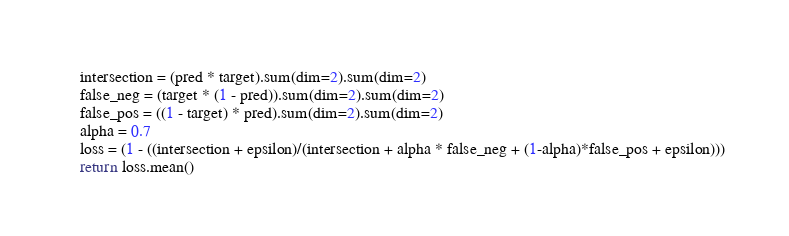Convert code to text. <code><loc_0><loc_0><loc_500><loc_500><_Python_>    intersection = (pred * target).sum(dim=2).sum(dim=2)
    false_neg = (target * (1 - pred)).sum(dim=2).sum(dim=2)
    false_pos = ((1 - target) * pred).sum(dim=2).sum(dim=2)
    alpha = 0.7
    loss = (1 - ((intersection + epsilon)/(intersection + alpha * false_neg + (1-alpha)*false_pos + epsilon)))
    return loss.mean()
</code> 